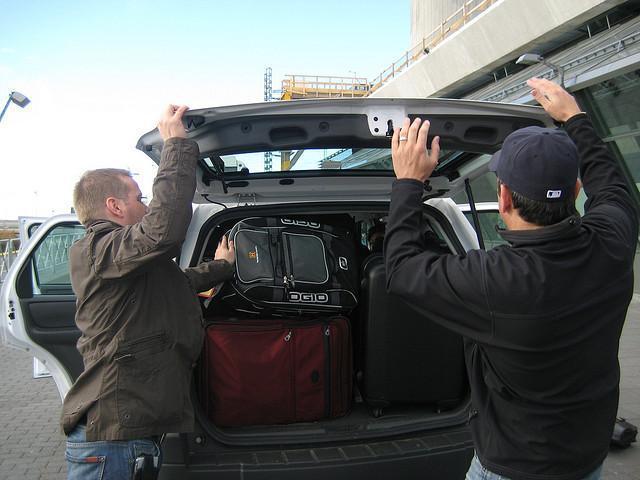How many people are there?
Give a very brief answer. 2. How many suitcases are visible?
Give a very brief answer. 2. How many rolls of toilet paper do you see?
Give a very brief answer. 0. 